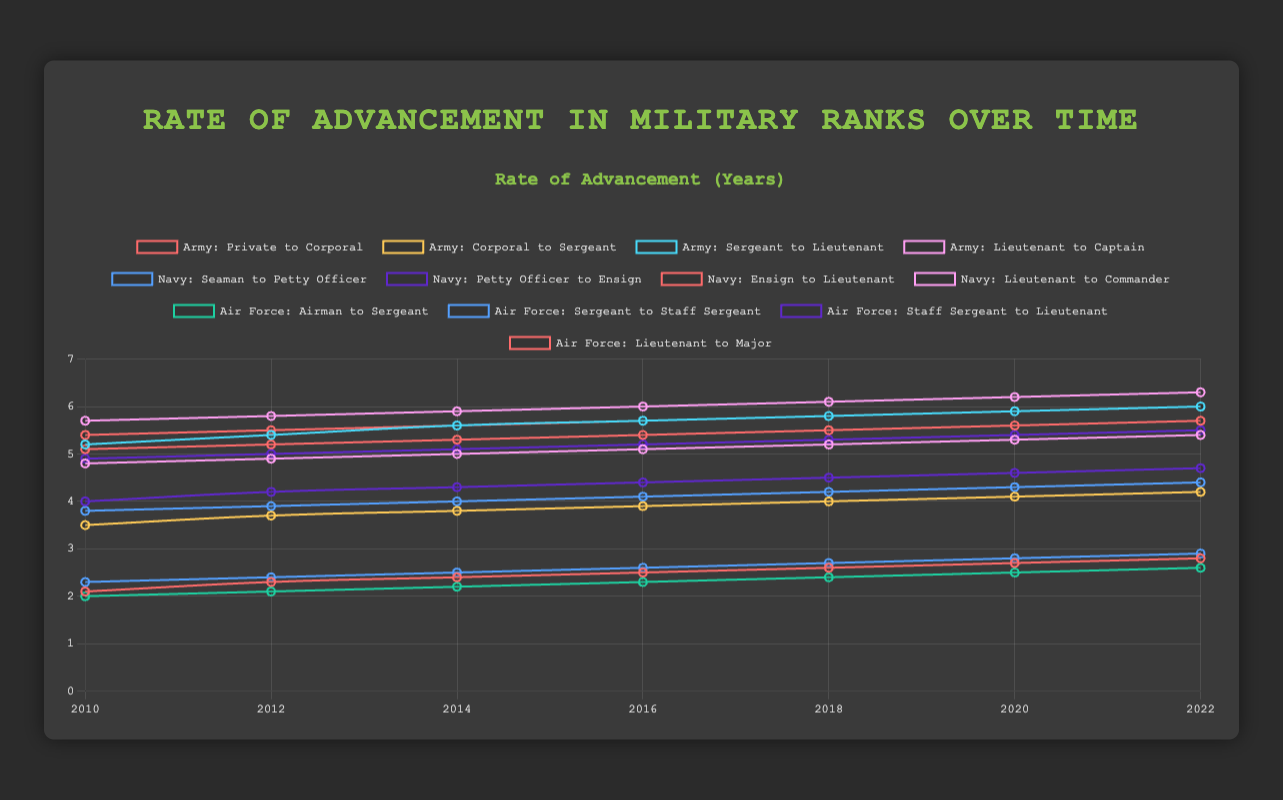Which branch has the shortest average advancement time from their first rank to their second in 2022? The average time from the first rank to the second in the Army is 2.8 years, in the Navy it is 2.9 years, and in the Air Force, it is 2.6 years. The Air Force has the shortest average advancement time.
Answer: Air Force How did the advancement time from Lieutenant to Captain in the Army change from 2010 to 2022? In 2010, the advancement time from Lieutenant to Captain was 4.8 years in the Army. By 2022, it increased to 5.4 years. This is an increase of 0.6 years.
Answer: Increased by 0.6 years Compare the Navy and Air Force in terms of advancement time from Ensign to Lieutenant in 2018. Which branch had a longer time? In 2018, the advancement time from Ensign to Lieutenant in the Navy was 5.5 years, and in the Air Force, it was 5.3 years. Therefore, the Navy had a longer advancement time.
Answer: Navy What is the average advancement time from Sergeant to Lieutenant across all years and branches? To find the average advancement time from Sergeant to Lieutenant, sum the values for each branch and year and then divide by the total number of entries. (5.2+5.4+5.6+5.7+5.8+5.9+6.0) for the Army, divided by 7 and similarly for Navy and Air Force. Summing these averages and dividing by 3 gives a combined average.
Answer: 5.5 years (assuming each year is equally weighted) Which rank transition has visually the steepest increasing trend in the Army over the years? The trend from the Sergeant to Lieutenant rank in the Army has the steepest increase, as its line is visibly getting steeper compared to others.
Answer: Sergeant to Lieutenant Which branch and rank transition have the highest starting value in 2010? In 2010, the transition from Lieutenant to Commander in the Navy had the highest starting value at 5.7 years.
Answer: Navy, Lieutenant to Commander Which rank transition in the Air Force shows the least change from 2010 to 2022? The transition from Airman to Sergeant in the Air Force shows the least change, starting at 2.0 years in 2010 and ending at 2.6 years in 2022; this is a small change of 0.6 years.
Answer: Airman to Sergeant What is the single largest increase in advancement time for any rank transition within one branch from 2010 to 2022? The largest increase is for the Sergeant to Lieutenant transition in the Army, which increases from 5.2 to 6.0 years, an increase of 0.8 years.
Answer: Sergeant to Lieutenant, Army 